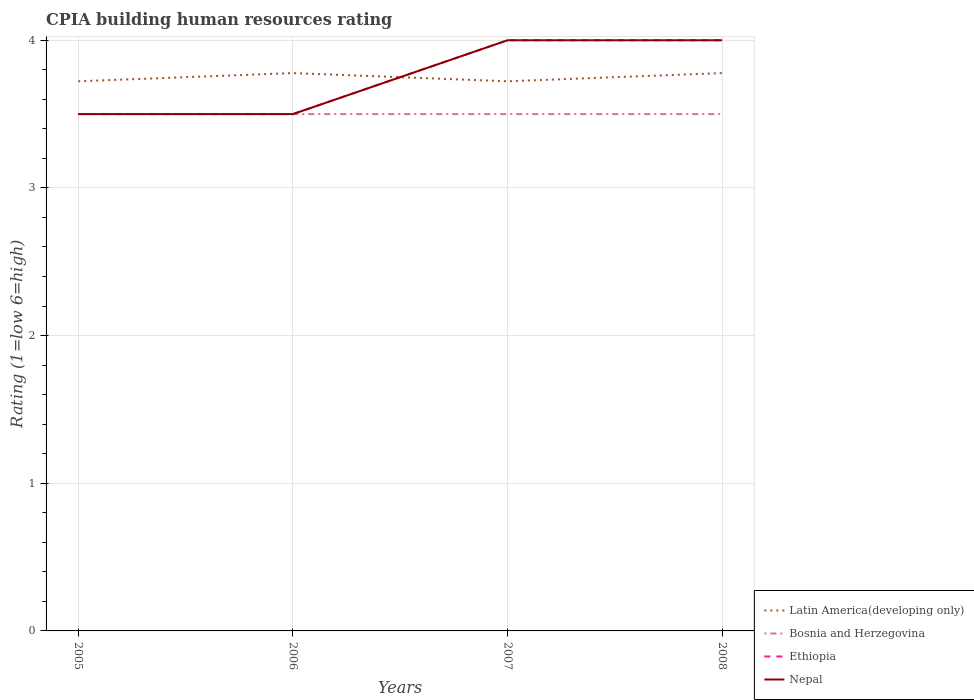Does the line corresponding to Ethiopia intersect with the line corresponding to Latin America(developing only)?
Make the answer very short. Yes. Across all years, what is the maximum CPIA rating in Nepal?
Ensure brevity in your answer.  3.5. What is the difference between the highest and the lowest CPIA rating in Latin America(developing only)?
Your answer should be very brief. 2. Is the CPIA rating in Latin America(developing only) strictly greater than the CPIA rating in Bosnia and Herzegovina over the years?
Your answer should be very brief. No. How many lines are there?
Your answer should be very brief. 4. How many years are there in the graph?
Your answer should be compact. 4. What is the difference between two consecutive major ticks on the Y-axis?
Provide a succinct answer. 1. What is the title of the graph?
Keep it short and to the point. CPIA building human resources rating. What is the label or title of the Y-axis?
Offer a very short reply. Rating (1=low 6=high). What is the Rating (1=low 6=high) in Latin America(developing only) in 2005?
Your response must be concise. 3.72. What is the Rating (1=low 6=high) in Bosnia and Herzegovina in 2005?
Ensure brevity in your answer.  3.5. What is the Rating (1=low 6=high) of Ethiopia in 2005?
Ensure brevity in your answer.  3.5. What is the Rating (1=low 6=high) of Nepal in 2005?
Provide a succinct answer. 3.5. What is the Rating (1=low 6=high) of Latin America(developing only) in 2006?
Your response must be concise. 3.78. What is the Rating (1=low 6=high) of Bosnia and Herzegovina in 2006?
Make the answer very short. 3.5. What is the Rating (1=low 6=high) of Nepal in 2006?
Offer a very short reply. 3.5. What is the Rating (1=low 6=high) of Latin America(developing only) in 2007?
Your answer should be compact. 3.72. What is the Rating (1=low 6=high) in Bosnia and Herzegovina in 2007?
Ensure brevity in your answer.  3.5. What is the Rating (1=low 6=high) of Ethiopia in 2007?
Give a very brief answer. 4. What is the Rating (1=low 6=high) of Nepal in 2007?
Ensure brevity in your answer.  4. What is the Rating (1=low 6=high) of Latin America(developing only) in 2008?
Offer a terse response. 3.78. What is the Rating (1=low 6=high) of Bosnia and Herzegovina in 2008?
Make the answer very short. 3.5. What is the Rating (1=low 6=high) in Ethiopia in 2008?
Give a very brief answer. 4. What is the Rating (1=low 6=high) in Nepal in 2008?
Offer a terse response. 4. Across all years, what is the maximum Rating (1=low 6=high) in Latin America(developing only)?
Ensure brevity in your answer.  3.78. Across all years, what is the maximum Rating (1=low 6=high) in Bosnia and Herzegovina?
Keep it short and to the point. 3.5. Across all years, what is the maximum Rating (1=low 6=high) in Ethiopia?
Your response must be concise. 4. Across all years, what is the minimum Rating (1=low 6=high) of Latin America(developing only)?
Your answer should be compact. 3.72. Across all years, what is the minimum Rating (1=low 6=high) in Ethiopia?
Provide a short and direct response. 3.5. Across all years, what is the minimum Rating (1=low 6=high) of Nepal?
Keep it short and to the point. 3.5. What is the total Rating (1=low 6=high) in Latin America(developing only) in the graph?
Your answer should be very brief. 15. What is the total Rating (1=low 6=high) of Bosnia and Herzegovina in the graph?
Give a very brief answer. 14. What is the total Rating (1=low 6=high) of Ethiopia in the graph?
Make the answer very short. 15. What is the total Rating (1=low 6=high) of Nepal in the graph?
Your response must be concise. 15. What is the difference between the Rating (1=low 6=high) of Latin America(developing only) in 2005 and that in 2006?
Offer a very short reply. -0.06. What is the difference between the Rating (1=low 6=high) in Bosnia and Herzegovina in 2005 and that in 2006?
Offer a very short reply. 0. What is the difference between the Rating (1=low 6=high) of Ethiopia in 2005 and that in 2006?
Your answer should be very brief. 0. What is the difference between the Rating (1=low 6=high) in Nepal in 2005 and that in 2006?
Your answer should be very brief. 0. What is the difference between the Rating (1=low 6=high) of Bosnia and Herzegovina in 2005 and that in 2007?
Your answer should be compact. 0. What is the difference between the Rating (1=low 6=high) of Ethiopia in 2005 and that in 2007?
Your response must be concise. -0.5. What is the difference between the Rating (1=low 6=high) of Nepal in 2005 and that in 2007?
Your answer should be compact. -0.5. What is the difference between the Rating (1=low 6=high) in Latin America(developing only) in 2005 and that in 2008?
Make the answer very short. -0.06. What is the difference between the Rating (1=low 6=high) of Ethiopia in 2005 and that in 2008?
Give a very brief answer. -0.5. What is the difference between the Rating (1=low 6=high) of Latin America(developing only) in 2006 and that in 2007?
Keep it short and to the point. 0.06. What is the difference between the Rating (1=low 6=high) in Bosnia and Herzegovina in 2006 and that in 2007?
Provide a short and direct response. 0. What is the difference between the Rating (1=low 6=high) of Ethiopia in 2006 and that in 2007?
Give a very brief answer. -0.5. What is the difference between the Rating (1=low 6=high) of Nepal in 2006 and that in 2007?
Provide a short and direct response. -0.5. What is the difference between the Rating (1=low 6=high) in Latin America(developing only) in 2006 and that in 2008?
Your response must be concise. 0. What is the difference between the Rating (1=low 6=high) in Ethiopia in 2006 and that in 2008?
Offer a terse response. -0.5. What is the difference between the Rating (1=low 6=high) in Latin America(developing only) in 2007 and that in 2008?
Your answer should be very brief. -0.06. What is the difference between the Rating (1=low 6=high) in Bosnia and Herzegovina in 2007 and that in 2008?
Your response must be concise. 0. What is the difference between the Rating (1=low 6=high) of Latin America(developing only) in 2005 and the Rating (1=low 6=high) of Bosnia and Herzegovina in 2006?
Make the answer very short. 0.22. What is the difference between the Rating (1=low 6=high) in Latin America(developing only) in 2005 and the Rating (1=low 6=high) in Ethiopia in 2006?
Provide a short and direct response. 0.22. What is the difference between the Rating (1=low 6=high) in Latin America(developing only) in 2005 and the Rating (1=low 6=high) in Nepal in 2006?
Your response must be concise. 0.22. What is the difference between the Rating (1=low 6=high) of Bosnia and Herzegovina in 2005 and the Rating (1=low 6=high) of Ethiopia in 2006?
Your response must be concise. 0. What is the difference between the Rating (1=low 6=high) in Bosnia and Herzegovina in 2005 and the Rating (1=low 6=high) in Nepal in 2006?
Keep it short and to the point. 0. What is the difference between the Rating (1=low 6=high) of Ethiopia in 2005 and the Rating (1=low 6=high) of Nepal in 2006?
Your response must be concise. 0. What is the difference between the Rating (1=low 6=high) of Latin America(developing only) in 2005 and the Rating (1=low 6=high) of Bosnia and Herzegovina in 2007?
Offer a very short reply. 0.22. What is the difference between the Rating (1=low 6=high) in Latin America(developing only) in 2005 and the Rating (1=low 6=high) in Ethiopia in 2007?
Keep it short and to the point. -0.28. What is the difference between the Rating (1=low 6=high) of Latin America(developing only) in 2005 and the Rating (1=low 6=high) of Nepal in 2007?
Give a very brief answer. -0.28. What is the difference between the Rating (1=low 6=high) in Bosnia and Herzegovina in 2005 and the Rating (1=low 6=high) in Ethiopia in 2007?
Provide a succinct answer. -0.5. What is the difference between the Rating (1=low 6=high) in Ethiopia in 2005 and the Rating (1=low 6=high) in Nepal in 2007?
Your answer should be very brief. -0.5. What is the difference between the Rating (1=low 6=high) of Latin America(developing only) in 2005 and the Rating (1=low 6=high) of Bosnia and Herzegovina in 2008?
Ensure brevity in your answer.  0.22. What is the difference between the Rating (1=low 6=high) in Latin America(developing only) in 2005 and the Rating (1=low 6=high) in Ethiopia in 2008?
Provide a short and direct response. -0.28. What is the difference between the Rating (1=low 6=high) of Latin America(developing only) in 2005 and the Rating (1=low 6=high) of Nepal in 2008?
Keep it short and to the point. -0.28. What is the difference between the Rating (1=low 6=high) in Bosnia and Herzegovina in 2005 and the Rating (1=low 6=high) in Ethiopia in 2008?
Provide a succinct answer. -0.5. What is the difference between the Rating (1=low 6=high) of Bosnia and Herzegovina in 2005 and the Rating (1=low 6=high) of Nepal in 2008?
Your response must be concise. -0.5. What is the difference between the Rating (1=low 6=high) of Latin America(developing only) in 2006 and the Rating (1=low 6=high) of Bosnia and Herzegovina in 2007?
Your answer should be compact. 0.28. What is the difference between the Rating (1=low 6=high) in Latin America(developing only) in 2006 and the Rating (1=low 6=high) in Ethiopia in 2007?
Offer a very short reply. -0.22. What is the difference between the Rating (1=low 6=high) in Latin America(developing only) in 2006 and the Rating (1=low 6=high) in Nepal in 2007?
Your answer should be compact. -0.22. What is the difference between the Rating (1=low 6=high) of Bosnia and Herzegovina in 2006 and the Rating (1=low 6=high) of Ethiopia in 2007?
Provide a short and direct response. -0.5. What is the difference between the Rating (1=low 6=high) of Latin America(developing only) in 2006 and the Rating (1=low 6=high) of Bosnia and Herzegovina in 2008?
Your answer should be compact. 0.28. What is the difference between the Rating (1=low 6=high) of Latin America(developing only) in 2006 and the Rating (1=low 6=high) of Ethiopia in 2008?
Keep it short and to the point. -0.22. What is the difference between the Rating (1=low 6=high) in Latin America(developing only) in 2006 and the Rating (1=low 6=high) in Nepal in 2008?
Ensure brevity in your answer.  -0.22. What is the difference between the Rating (1=low 6=high) of Ethiopia in 2006 and the Rating (1=low 6=high) of Nepal in 2008?
Offer a very short reply. -0.5. What is the difference between the Rating (1=low 6=high) in Latin America(developing only) in 2007 and the Rating (1=low 6=high) in Bosnia and Herzegovina in 2008?
Your answer should be compact. 0.22. What is the difference between the Rating (1=low 6=high) in Latin America(developing only) in 2007 and the Rating (1=low 6=high) in Ethiopia in 2008?
Your response must be concise. -0.28. What is the difference between the Rating (1=low 6=high) in Latin America(developing only) in 2007 and the Rating (1=low 6=high) in Nepal in 2008?
Provide a short and direct response. -0.28. What is the difference between the Rating (1=low 6=high) in Ethiopia in 2007 and the Rating (1=low 6=high) in Nepal in 2008?
Ensure brevity in your answer.  0. What is the average Rating (1=low 6=high) in Latin America(developing only) per year?
Offer a terse response. 3.75. What is the average Rating (1=low 6=high) of Ethiopia per year?
Make the answer very short. 3.75. What is the average Rating (1=low 6=high) of Nepal per year?
Provide a succinct answer. 3.75. In the year 2005, what is the difference between the Rating (1=low 6=high) in Latin America(developing only) and Rating (1=low 6=high) in Bosnia and Herzegovina?
Offer a terse response. 0.22. In the year 2005, what is the difference between the Rating (1=low 6=high) in Latin America(developing only) and Rating (1=low 6=high) in Ethiopia?
Give a very brief answer. 0.22. In the year 2005, what is the difference between the Rating (1=low 6=high) in Latin America(developing only) and Rating (1=low 6=high) in Nepal?
Offer a terse response. 0.22. In the year 2005, what is the difference between the Rating (1=low 6=high) of Bosnia and Herzegovina and Rating (1=low 6=high) of Nepal?
Provide a short and direct response. 0. In the year 2006, what is the difference between the Rating (1=low 6=high) of Latin America(developing only) and Rating (1=low 6=high) of Bosnia and Herzegovina?
Your response must be concise. 0.28. In the year 2006, what is the difference between the Rating (1=low 6=high) of Latin America(developing only) and Rating (1=low 6=high) of Ethiopia?
Offer a very short reply. 0.28. In the year 2006, what is the difference between the Rating (1=low 6=high) of Latin America(developing only) and Rating (1=low 6=high) of Nepal?
Your response must be concise. 0.28. In the year 2006, what is the difference between the Rating (1=low 6=high) in Bosnia and Herzegovina and Rating (1=low 6=high) in Ethiopia?
Make the answer very short. 0. In the year 2006, what is the difference between the Rating (1=low 6=high) in Bosnia and Herzegovina and Rating (1=low 6=high) in Nepal?
Offer a terse response. 0. In the year 2007, what is the difference between the Rating (1=low 6=high) in Latin America(developing only) and Rating (1=low 6=high) in Bosnia and Herzegovina?
Your answer should be compact. 0.22. In the year 2007, what is the difference between the Rating (1=low 6=high) in Latin America(developing only) and Rating (1=low 6=high) in Ethiopia?
Your response must be concise. -0.28. In the year 2007, what is the difference between the Rating (1=low 6=high) in Latin America(developing only) and Rating (1=low 6=high) in Nepal?
Provide a short and direct response. -0.28. In the year 2007, what is the difference between the Rating (1=low 6=high) of Bosnia and Herzegovina and Rating (1=low 6=high) of Ethiopia?
Ensure brevity in your answer.  -0.5. In the year 2008, what is the difference between the Rating (1=low 6=high) in Latin America(developing only) and Rating (1=low 6=high) in Bosnia and Herzegovina?
Keep it short and to the point. 0.28. In the year 2008, what is the difference between the Rating (1=low 6=high) in Latin America(developing only) and Rating (1=low 6=high) in Ethiopia?
Provide a short and direct response. -0.22. In the year 2008, what is the difference between the Rating (1=low 6=high) in Latin America(developing only) and Rating (1=low 6=high) in Nepal?
Make the answer very short. -0.22. What is the ratio of the Rating (1=low 6=high) of Latin America(developing only) in 2005 to that in 2006?
Provide a succinct answer. 0.99. What is the ratio of the Rating (1=low 6=high) in Ethiopia in 2005 to that in 2007?
Ensure brevity in your answer.  0.88. What is the ratio of the Rating (1=low 6=high) of Nepal in 2005 to that in 2007?
Ensure brevity in your answer.  0.88. What is the ratio of the Rating (1=low 6=high) in Latin America(developing only) in 2005 to that in 2008?
Keep it short and to the point. 0.99. What is the ratio of the Rating (1=low 6=high) of Ethiopia in 2005 to that in 2008?
Give a very brief answer. 0.88. What is the ratio of the Rating (1=low 6=high) of Nepal in 2005 to that in 2008?
Keep it short and to the point. 0.88. What is the ratio of the Rating (1=low 6=high) of Latin America(developing only) in 2006 to that in 2007?
Your answer should be compact. 1.01. What is the ratio of the Rating (1=low 6=high) of Bosnia and Herzegovina in 2006 to that in 2007?
Offer a very short reply. 1. What is the ratio of the Rating (1=low 6=high) in Ethiopia in 2006 to that in 2007?
Provide a succinct answer. 0.88. What is the ratio of the Rating (1=low 6=high) in Nepal in 2006 to that in 2007?
Provide a succinct answer. 0.88. What is the ratio of the Rating (1=low 6=high) of Nepal in 2006 to that in 2008?
Ensure brevity in your answer.  0.88. What is the ratio of the Rating (1=low 6=high) of Bosnia and Herzegovina in 2007 to that in 2008?
Make the answer very short. 1. What is the ratio of the Rating (1=low 6=high) of Ethiopia in 2007 to that in 2008?
Your response must be concise. 1. What is the ratio of the Rating (1=low 6=high) of Nepal in 2007 to that in 2008?
Make the answer very short. 1. What is the difference between the highest and the second highest Rating (1=low 6=high) of Bosnia and Herzegovina?
Your response must be concise. 0. What is the difference between the highest and the second highest Rating (1=low 6=high) of Ethiopia?
Your response must be concise. 0. What is the difference between the highest and the lowest Rating (1=low 6=high) in Latin America(developing only)?
Provide a succinct answer. 0.06. What is the difference between the highest and the lowest Rating (1=low 6=high) of Bosnia and Herzegovina?
Keep it short and to the point. 0. What is the difference between the highest and the lowest Rating (1=low 6=high) in Ethiopia?
Ensure brevity in your answer.  0.5. What is the difference between the highest and the lowest Rating (1=low 6=high) in Nepal?
Provide a short and direct response. 0.5. 